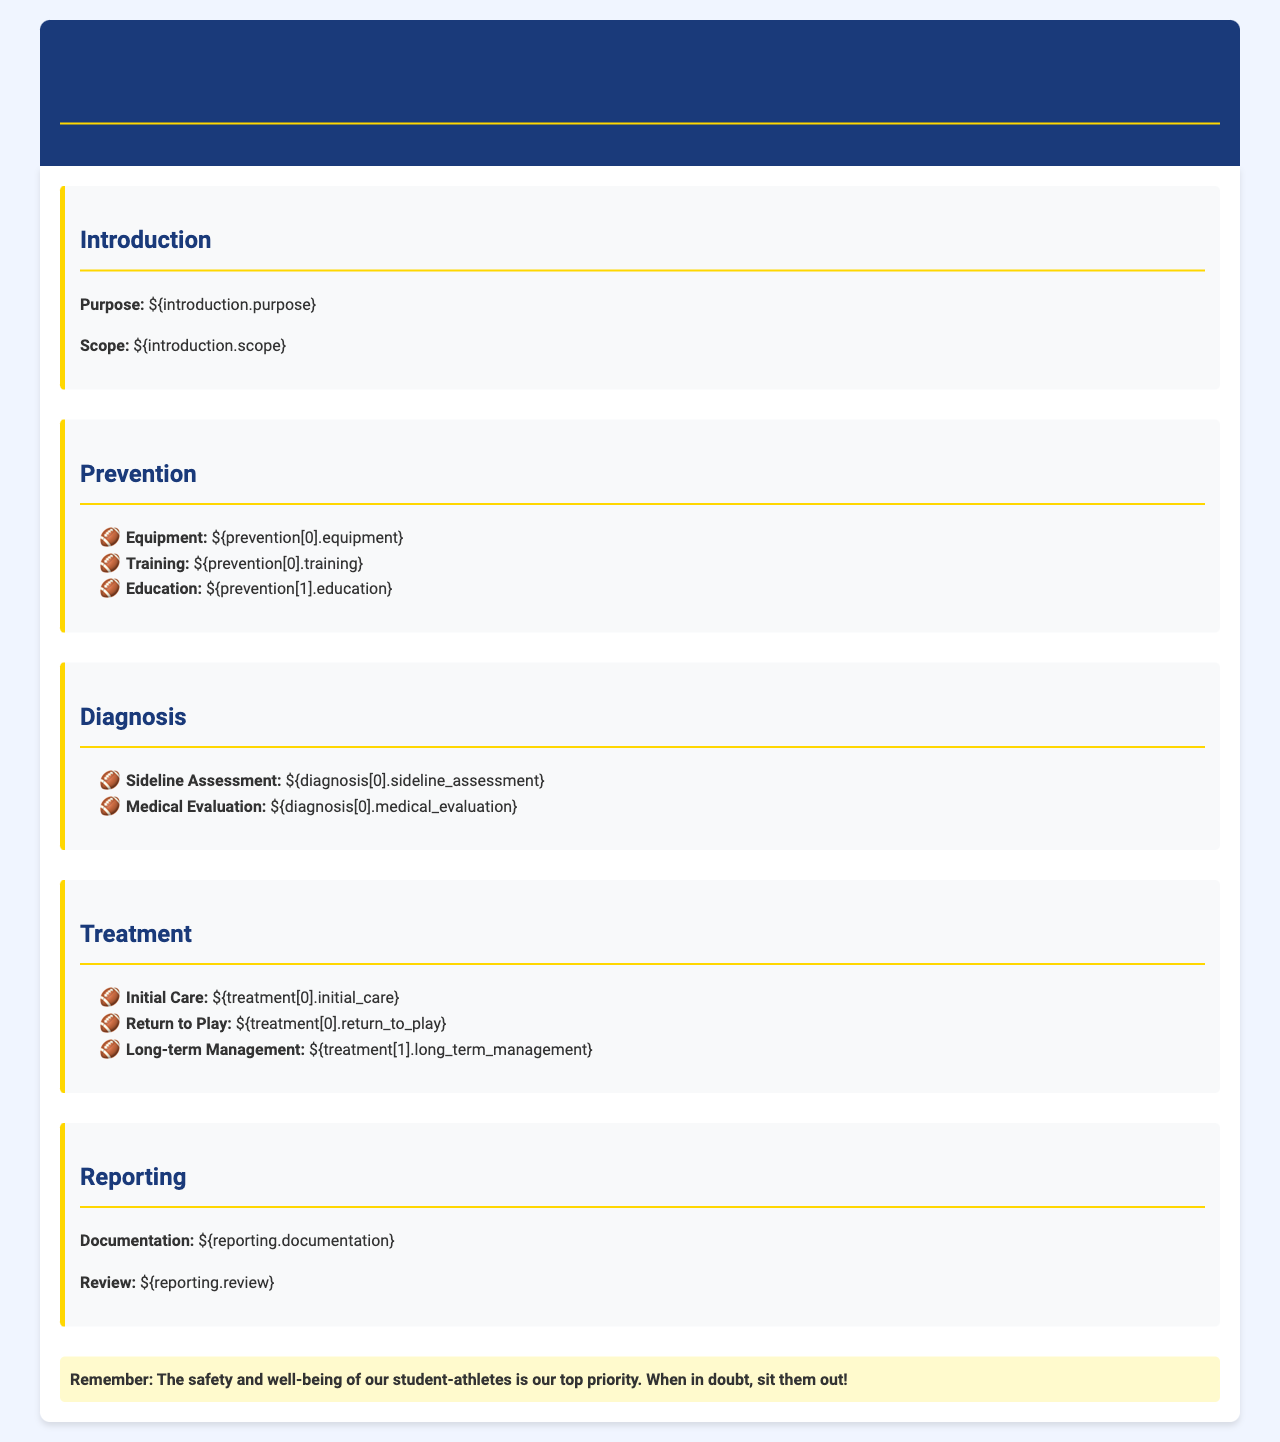What is the purpose of the protocol? The purpose of the protocol is outlined in the introduction section.
Answer: Prevention of concussions What are the three aspects of prevention listed? The prevention section specifies three aspects: equipment, training, and education.
Answer: Equipment, training, education What is the initial care mentioned in the treatment section? The initial care is specifically defined in the treatment section.
Answer: Immediate medical evaluation How many evaluations are mentioned in the diagnosis section? The diagnosis section includes two types of evaluations: sideline assessment and medical evaluation.
Answer: Two What is the highlights message about student-athlete safety? The highlight section emphasizes the safety and well-being of student-athletes.
Answer: Sit them out! 